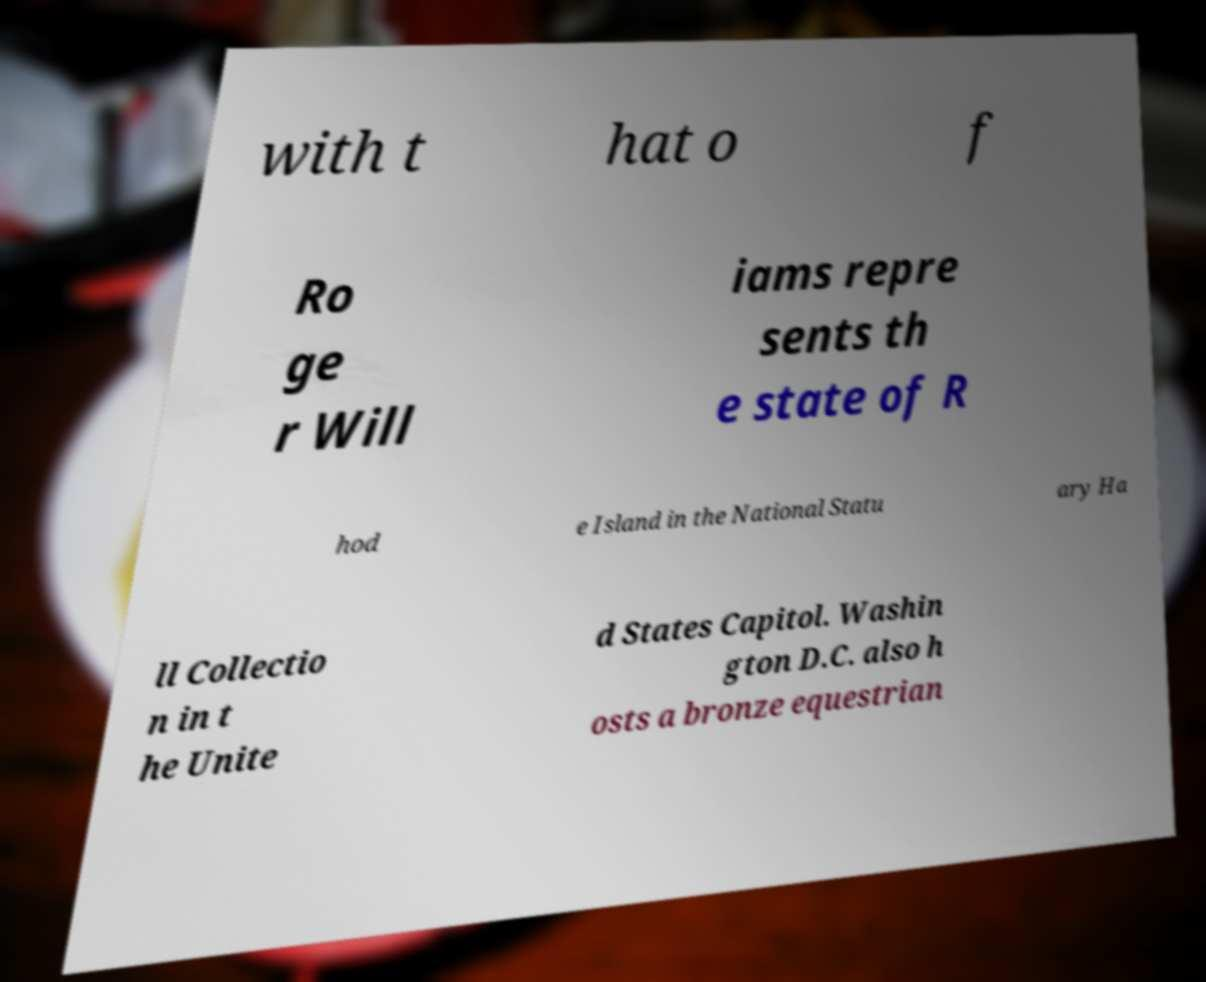Can you read and provide the text displayed in the image?This photo seems to have some interesting text. Can you extract and type it out for me? with t hat o f Ro ge r Will iams repre sents th e state of R hod e Island in the National Statu ary Ha ll Collectio n in t he Unite d States Capitol. Washin gton D.C. also h osts a bronze equestrian 